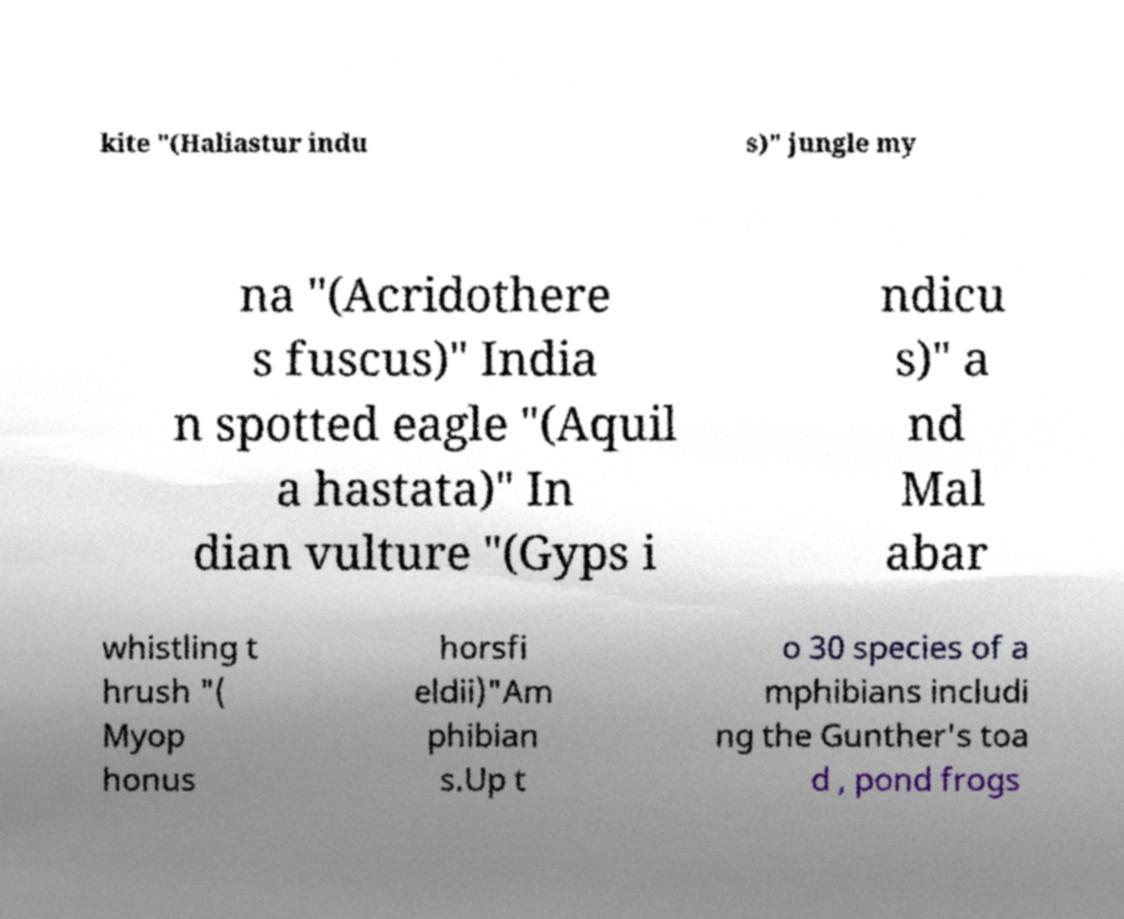For documentation purposes, I need the text within this image transcribed. Could you provide that? kite "(Haliastur indu s)" jungle my na "(Acridothere s fuscus)" India n spotted eagle "(Aquil a hastata)" In dian vulture "(Gyps i ndicu s)" a nd Mal abar whistling t hrush "( Myop honus horsfi eldii)"Am phibian s.Up t o 30 species of a mphibians includi ng the Gunther's toa d , pond frogs 